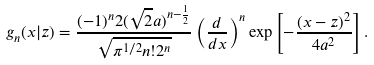Convert formula to latex. <formula><loc_0><loc_0><loc_500><loc_500>g _ { n } ( x | z ) = \frac { ( - 1 ) ^ { n } 2 ( \sqrt { 2 } a ) ^ { n - \frac { 1 } { 2 } } } { \sqrt { \pi ^ { 1 / 2 } n ! 2 ^ { n } } } \left ( \frac { d } { d x } \right ) ^ { n } \exp \left [ - \frac { ( x - z ) ^ { 2 } } { 4 a ^ { 2 } } \right ] .</formula> 